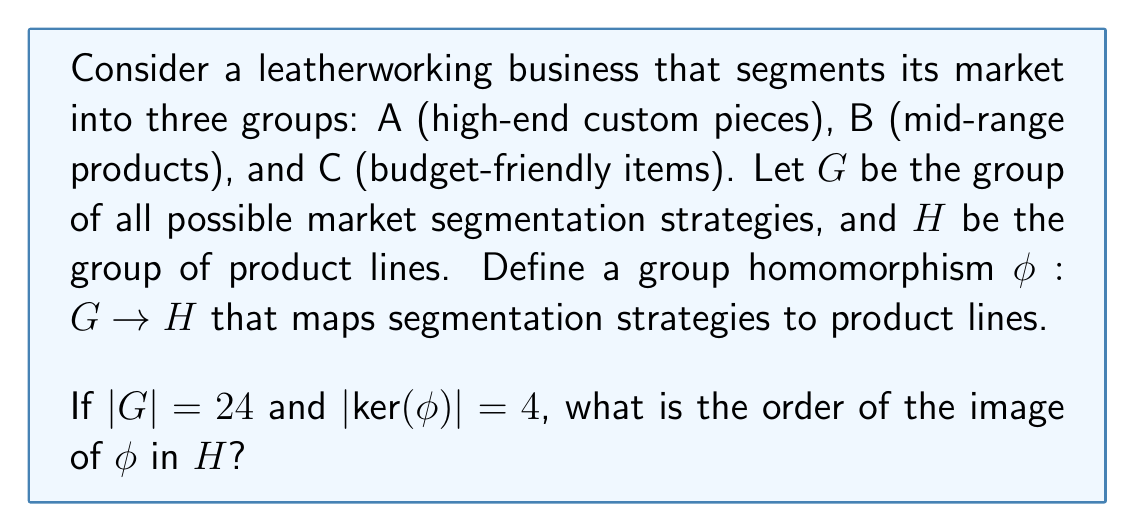Teach me how to tackle this problem. To solve this problem, we'll use the First Isomorphism Theorem from group theory and apply it to our market segmentation scenario.

1) The First Isomorphism Theorem states that for a group homomorphism $\phi: G \rightarrow H$, we have:

   $G/\text{ker}(\phi) \cong \text{Im}(\phi)$

2) This implies that:

   $|G/\text{ker}(\phi)| = |\text{Im}(\phi)|$

3) We know that for any subgroup K of a finite group G:

   $|G| = |G/K| \cdot |K|$

4) In our case, $|G| = 24$ and $|\text{ker}(\phi)| = 4$. Let's call $|\text{Im}(\phi)| = x$. Then:

   $24 = x \cdot 4$

5) Solving for x:

   $x = 24 / 4 = 6$

Therefore, the order of the image of $\phi$ in H is 6.

In the context of our leatherworking business, this means that while there are 24 possible market segmentation strategies, they map to only 6 distinct product lines. This could represent, for example, two variations of each of our three main product categories (A, B, and C).
Answer: The order of the image of $\phi$ in H is 6. 